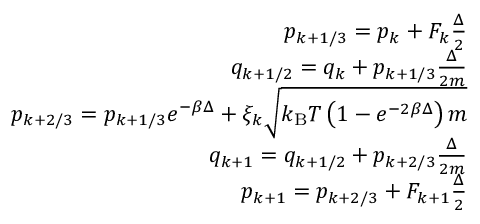Convert formula to latex. <formula><loc_0><loc_0><loc_500><loc_500>\begin{array} { r } { p _ { k + 1 / 3 } = p _ { k } + F _ { k } \frac { \Delta } { 2 } } \\ { q _ { k + 1 / 2 } = q _ { k } + p _ { k + 1 / 3 } \frac { \Delta } { 2 m } } \\ { p _ { k + 2 / 3 } = p _ { k + 1 / 3 } e ^ { - \beta \Delta } + \xi _ { k } \sqrt { k _ { B } T \left ( 1 - e ^ { - 2 \beta \Delta } \right ) m } } \\ { q _ { k + 1 } = q _ { k + 1 / 2 } + p _ { k + 2 / 3 } \frac { \Delta } { 2 m } } \\ { p _ { k + 1 } = p _ { k + 2 / 3 } + F _ { k + 1 } \frac { \Delta } { 2 } } \end{array}</formula> 